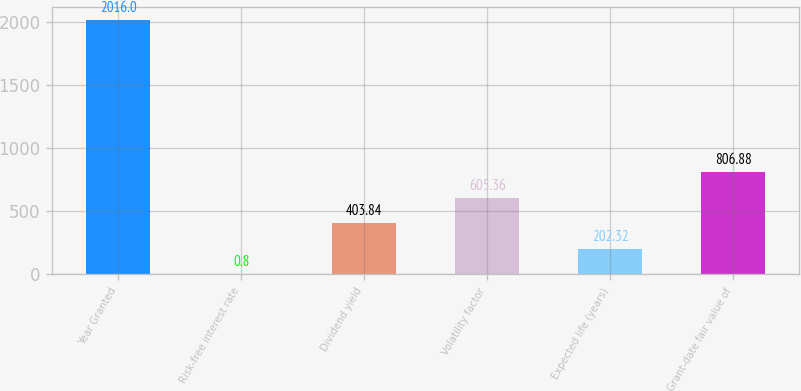Convert chart to OTSL. <chart><loc_0><loc_0><loc_500><loc_500><bar_chart><fcel>Year Granted<fcel>Risk-free interest rate<fcel>Dividend yield<fcel>Volatility factor<fcel>Expected life (years)<fcel>Grant-date fair value of<nl><fcel>2016<fcel>0.8<fcel>403.84<fcel>605.36<fcel>202.32<fcel>806.88<nl></chart> 